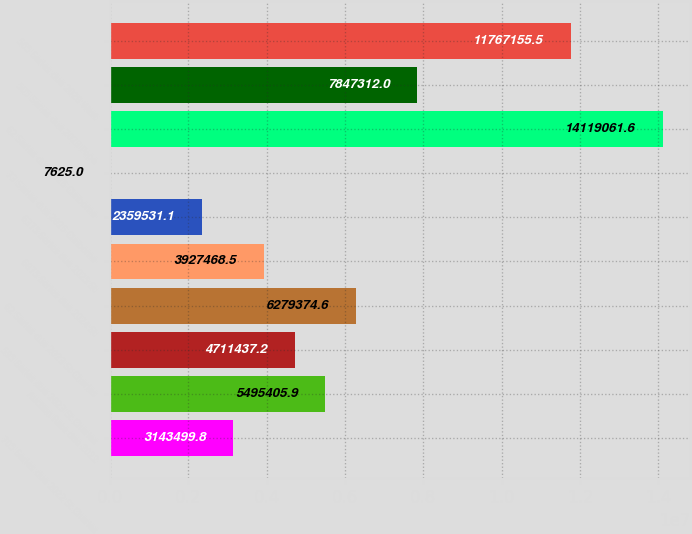Convert chart. <chart><loc_0><loc_0><loc_500><loc_500><bar_chart><fcel>705 Series due 2022 St Charles<fcel>Auction Rate due 2022<fcel>595 Series due 2023 St Charles<fcel>62 Series due 2023 St Charles<fcel>6875 Series due 2024 St<fcel>6375 Series due 2025 St<fcel>73 Series due 2025 Claiborne<fcel>62 Series due 2026 Claiborne<fcel>505 Series due 2028 Pope<fcel>565 Series due 2028 West<nl><fcel>3.1435e+06<fcel>5.49541e+06<fcel>4.71144e+06<fcel>6.27937e+06<fcel>3.92747e+06<fcel>2.35953e+06<fcel>7625<fcel>1.41191e+07<fcel>7.84731e+06<fcel>1.17672e+07<nl></chart> 